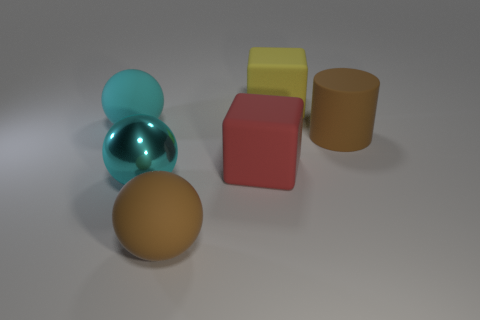How many things are big brown matte cylinders or large rubber blocks that are behind the brown rubber cylinder?
Give a very brief answer. 2. There is a ball behind the big cube in front of the large yellow matte block; how many metallic spheres are in front of it?
Keep it short and to the point. 1. What number of matte balls are there?
Your response must be concise. 2. There is a rubber block in front of the brown rubber cylinder; is it the same size as the yellow matte block?
Keep it short and to the point. Yes. What number of rubber things are either big brown things or cyan objects?
Keep it short and to the point. 3. There is a large brown rubber thing that is in front of the brown matte cylinder; what number of large yellow rubber blocks are in front of it?
Provide a short and direct response. 0. There is a big rubber object that is both to the left of the red rubber block and in front of the large brown matte cylinder; what shape is it?
Give a very brief answer. Sphere. What material is the brown object right of the large yellow matte block that is left of the rubber object that is right of the yellow object?
Your answer should be very brief. Rubber. What is the yellow object made of?
Make the answer very short. Rubber. Is the material of the big cylinder the same as the cyan ball that is in front of the big cyan matte object?
Provide a succinct answer. No. 